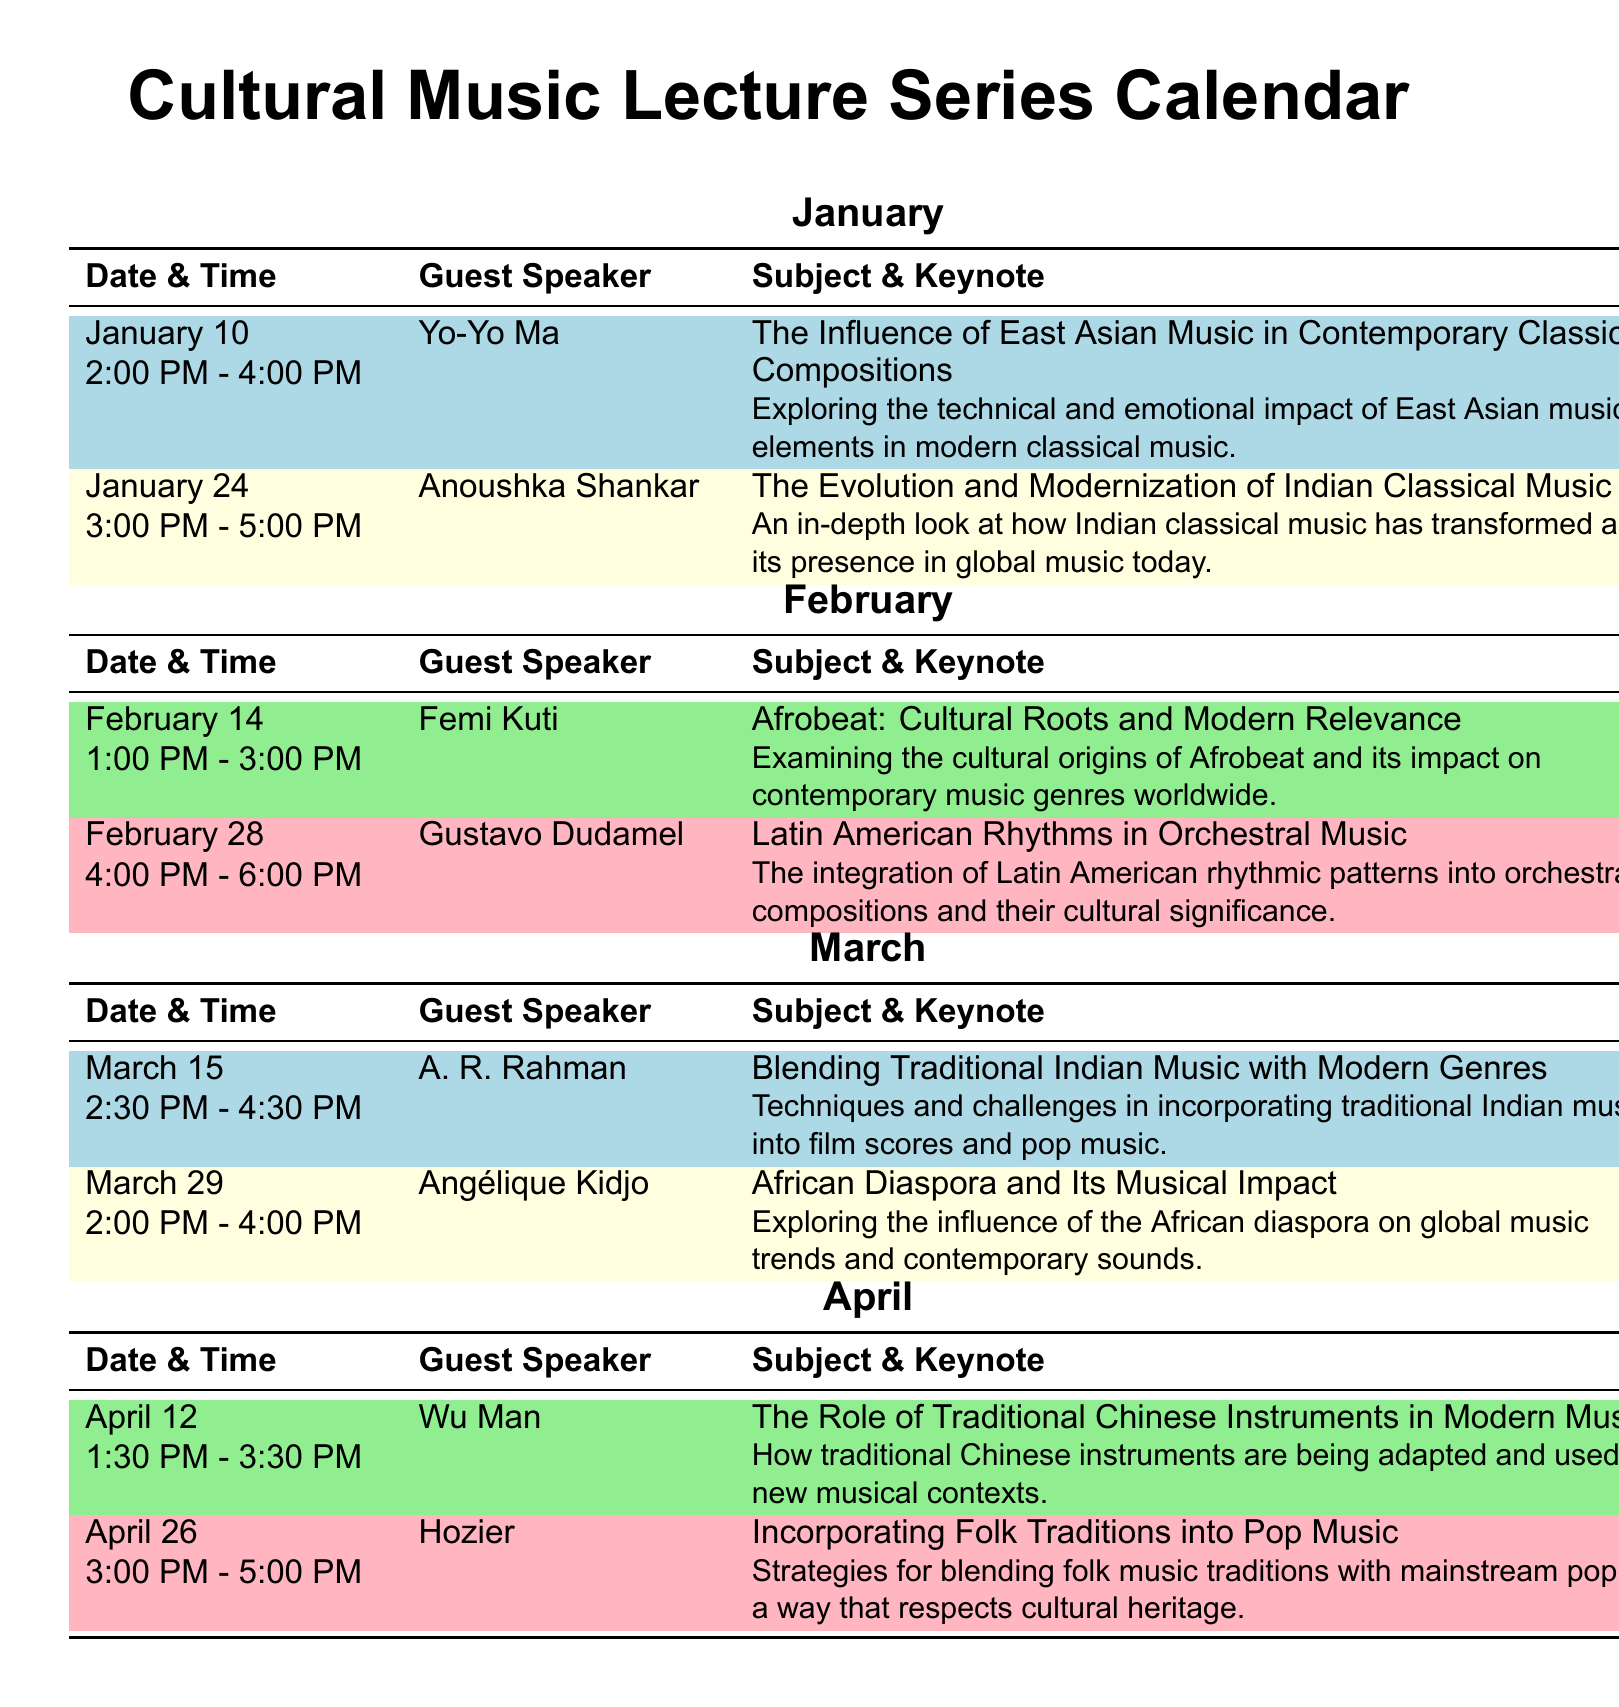What is the date and time of the lecture by Yo-Yo Ma? The lecture by Yo-Yo Ma is scheduled for January 10 from 2:00 PM to 4:00 PM.
Answer: January 10, 2:00 PM - 4:00 PM Who is the guest speaker on February 28? The guest speaker on February 28 is Gustavo Dudamel.
Answer: Gustavo Dudamel What subject will Anoushka Shankar discuss? Anoushka Shankar will discuss the evolution and modernization of Indian classical music.
Answer: The Evolution and Modernization of Indian Classical Music Which month features a lecture by A. R. Rahman? The lecture by A. R. Rahman is featured in March.
Answer: March How many lectures are scheduled in April? There are two lectures scheduled in April.
Answer: Two lectures What is the focus of Femi Kuti's lecture? Femi Kuti's lecture focuses on Afrobeat, its cultural roots, and modern relevance.
Answer: Afrobeat: Cultural Roots and Modern Relevance What time does the lecture by Wu Man begin? The lecture by Wu Man begins at 1:30 PM.
Answer: 1:30 PM Which guest speaker is associated with folk traditions? Hozier is the guest speaker associated with incorporating folk traditions.
Answer: Hozier What color is used for the lecture schedule in February? The color used for the lecture schedule in February is light green and light pink.
Answer: Light green and light pink 